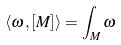Convert formula to latex. <formula><loc_0><loc_0><loc_500><loc_500>\langle \omega , [ M ] \rangle = \int _ { M } \omega</formula> 